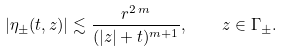Convert formula to latex. <formula><loc_0><loc_0><loc_500><loc_500>| \eta _ { \pm } ( t , z ) | \lesssim \frac { r ^ { 2 \, m } } { ( | z | + t ) ^ { m + 1 } } , \quad z \in \Gamma _ { \pm } .</formula> 